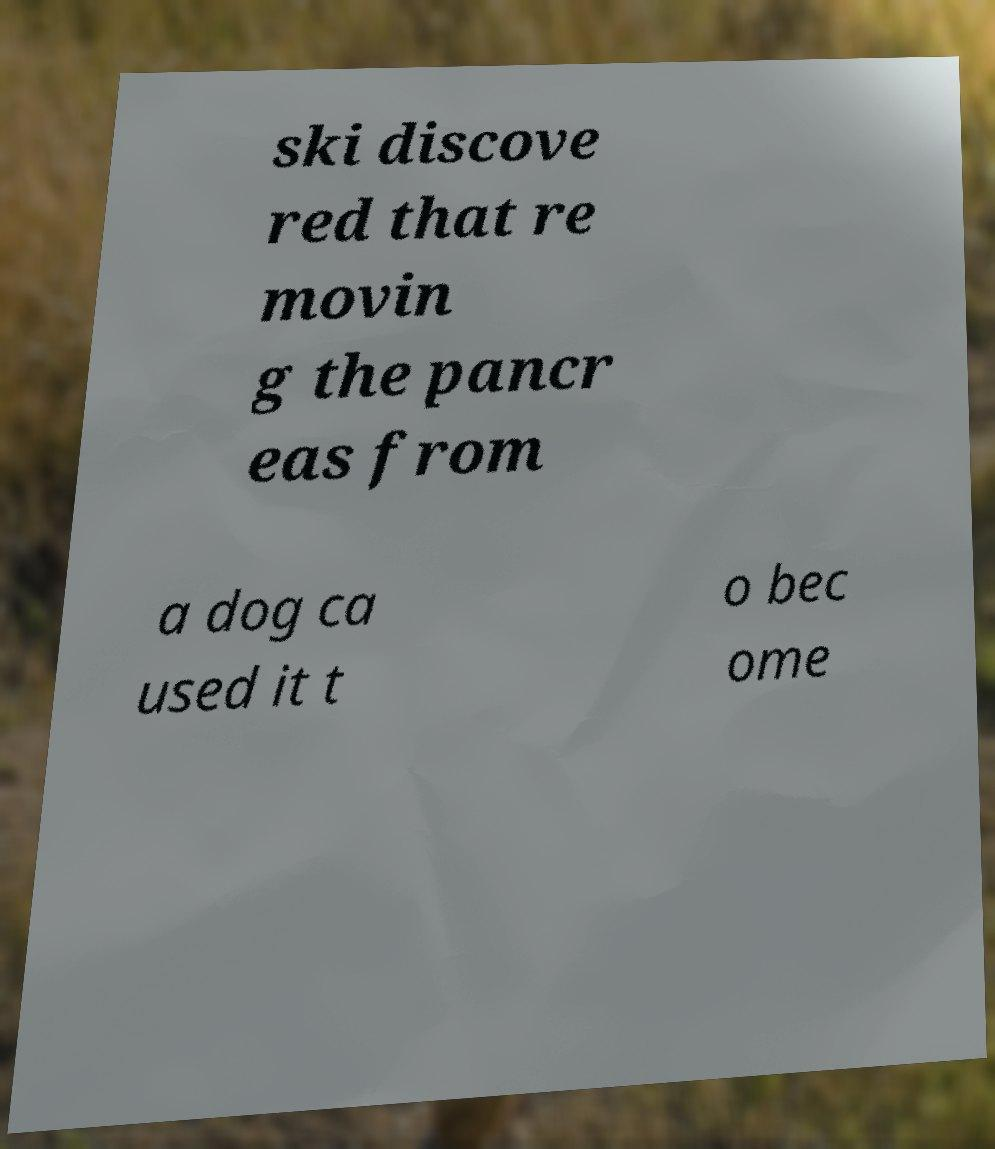Can you accurately transcribe the text from the provided image for me? ski discove red that re movin g the pancr eas from a dog ca used it t o bec ome 